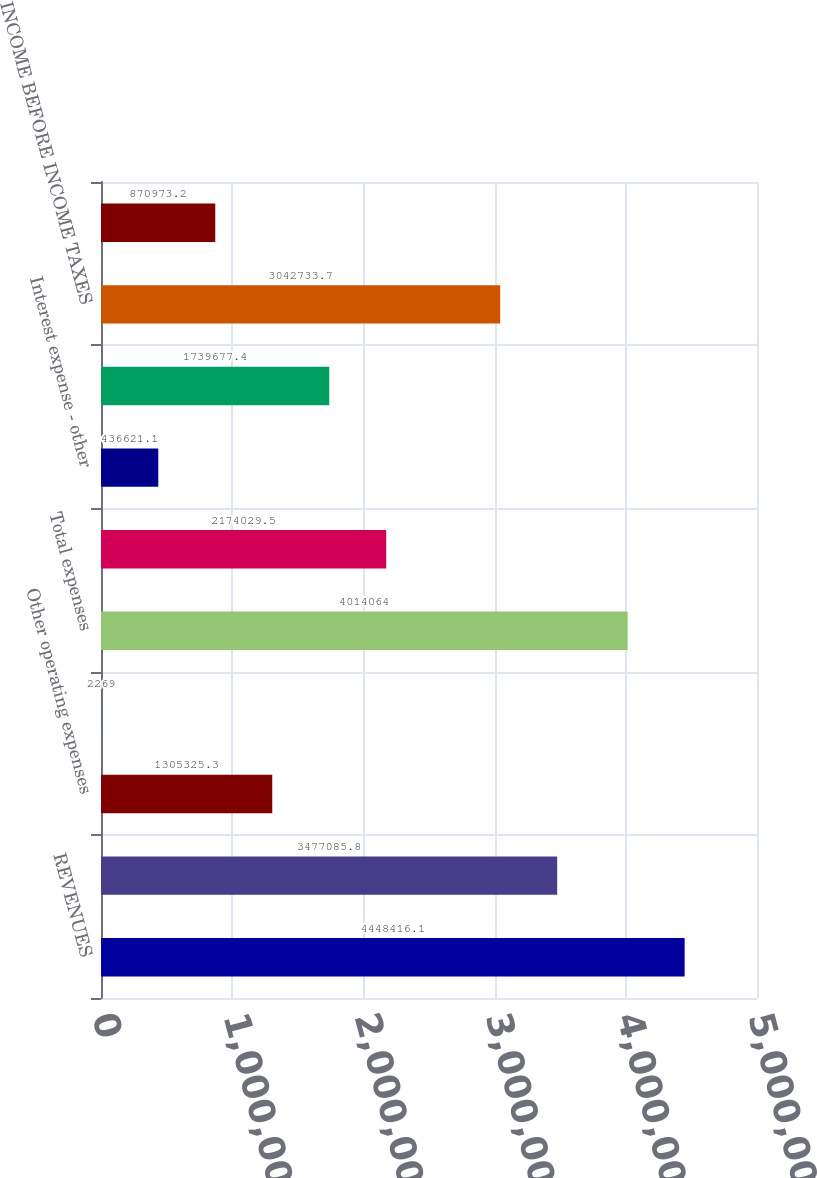<chart> <loc_0><loc_0><loc_500><loc_500><bar_chart><fcel>REVENUES<fcel>Purchased power from<fcel>Other operating expenses<fcel>Provision for depreciation<fcel>Total expenses<fcel>OPERATING INCOME<fcel>Interest expense - other<fcel>Total other income (expense)<fcel>INCOME BEFORE INCOME TAXES<fcel>INCOME TAXES<nl><fcel>4.44842e+06<fcel>3.47709e+06<fcel>1.30533e+06<fcel>2269<fcel>4.01406e+06<fcel>2.17403e+06<fcel>436621<fcel>1.73968e+06<fcel>3.04273e+06<fcel>870973<nl></chart> 